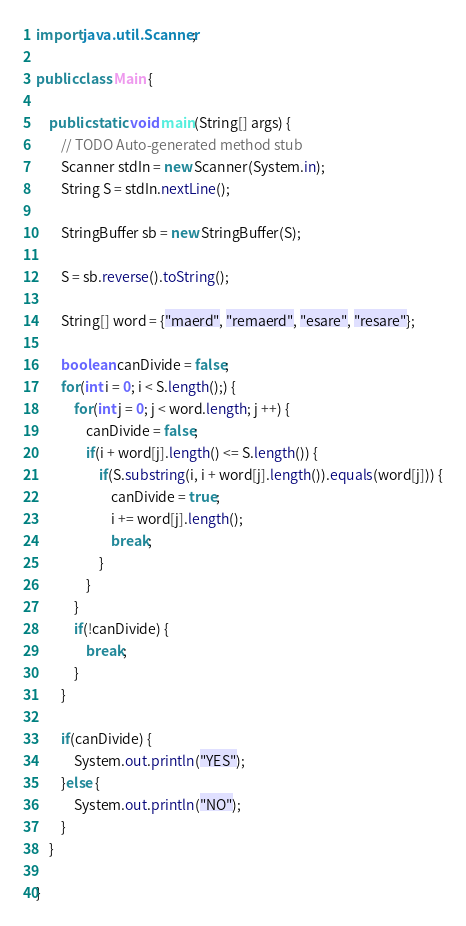<code> <loc_0><loc_0><loc_500><loc_500><_Java_>import java.util.Scanner;

public class Main {

	public static void main(String[] args) {
		// TODO Auto-generated method stub
		Scanner stdIn = new Scanner(System.in);
		String S = stdIn.nextLine();
		
		StringBuffer sb = new StringBuffer(S);
		
		S = sb.reverse().toString();
		
		String[] word = {"maerd", "remaerd", "esare", "resare"};
		
		boolean canDivide = false;
		for(int i = 0; i < S.length();) {
			for(int j = 0; j < word.length; j ++) {
				canDivide = false;
				if(i + word[j].length() <= S.length()) {
					if(S.substring(i, i + word[j].length()).equals(word[j])) {
						canDivide = true;
						i += word[j].length();
						break;
					}
				}
			}
			if(!canDivide) {
				break;
			}
		}
		
		if(canDivide) {
			System.out.println("YES");
		}else {
			System.out.println("NO");
		}
	}

}</code> 